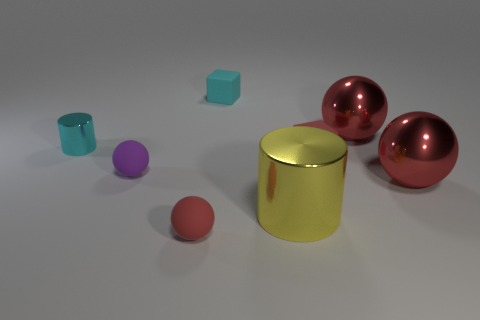If we were to organize these objects from largest to smallest, which order would they go in? Organized from largest to smallest, the order would be: the large metallic cylinder first, then the two metallic spheres which appear to be the same size, followed by the small matte cylinder, and finally the small matte cube. 